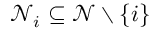Convert formula to latex. <formula><loc_0><loc_0><loc_500><loc_500>\mathcal { N } _ { i } \subseteq \mathcal { N } \ \{ i \}</formula> 